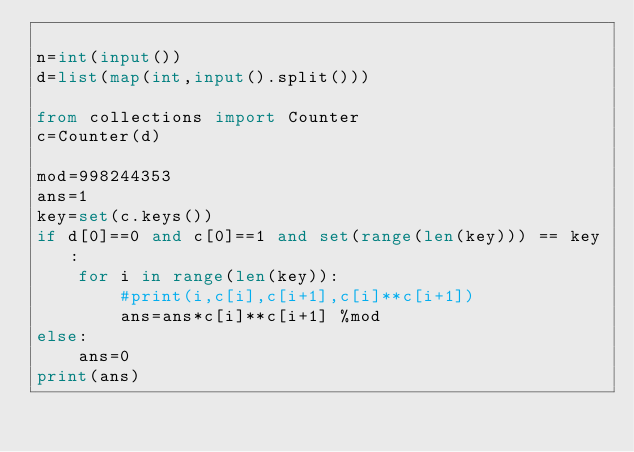<code> <loc_0><loc_0><loc_500><loc_500><_Python_>
n=int(input())
d=list(map(int,input().split()))

from collections import Counter
c=Counter(d)

mod=998244353
ans=1
key=set(c.keys())
if d[0]==0 and c[0]==1 and set(range(len(key))) == key:
    for i in range(len(key)):
        #print(i,c[i],c[i+1],c[i]**c[i+1])
        ans=ans*c[i]**c[i+1] %mod
else:
    ans=0
print(ans)</code> 